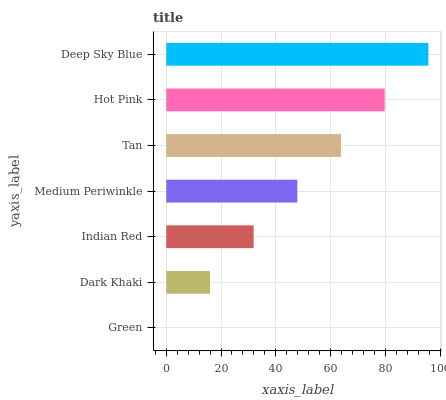Is Green the minimum?
Answer yes or no. Yes. Is Deep Sky Blue the maximum?
Answer yes or no. Yes. Is Dark Khaki the minimum?
Answer yes or no. No. Is Dark Khaki the maximum?
Answer yes or no. No. Is Dark Khaki greater than Green?
Answer yes or no. Yes. Is Green less than Dark Khaki?
Answer yes or no. Yes. Is Green greater than Dark Khaki?
Answer yes or no. No. Is Dark Khaki less than Green?
Answer yes or no. No. Is Medium Periwinkle the high median?
Answer yes or no. Yes. Is Medium Periwinkle the low median?
Answer yes or no. Yes. Is Green the high median?
Answer yes or no. No. Is Hot Pink the low median?
Answer yes or no. No. 